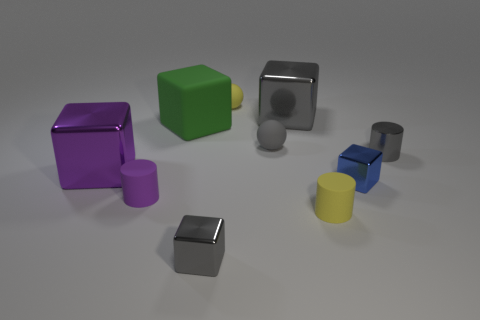Subtract all big purple cubes. How many cubes are left? 4 Subtract all blue cubes. How many cubes are left? 4 Subtract all brown blocks. Subtract all yellow cylinders. How many blocks are left? 5 Subtract all cylinders. How many objects are left? 7 Subtract 1 purple cylinders. How many objects are left? 9 Subtract all small gray metal objects. Subtract all tiny yellow things. How many objects are left? 6 Add 6 yellow matte cylinders. How many yellow matte cylinders are left? 7 Add 1 cyan rubber cylinders. How many cyan rubber cylinders exist? 1 